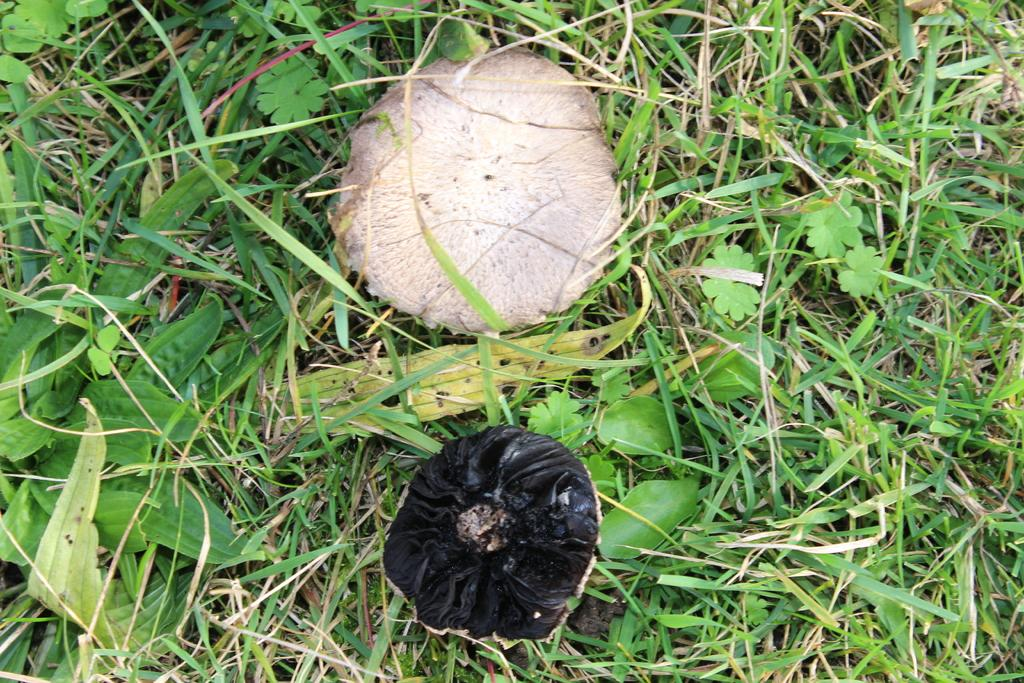What type of fungi can be seen in the image? There are mushrooms in the image. What type of vegetation is present in the image? There is grass and plants in the image. What type of fiction is the man reading in the image? There is no man or fiction present in the image; it only features mushrooms, grass, and plants. 